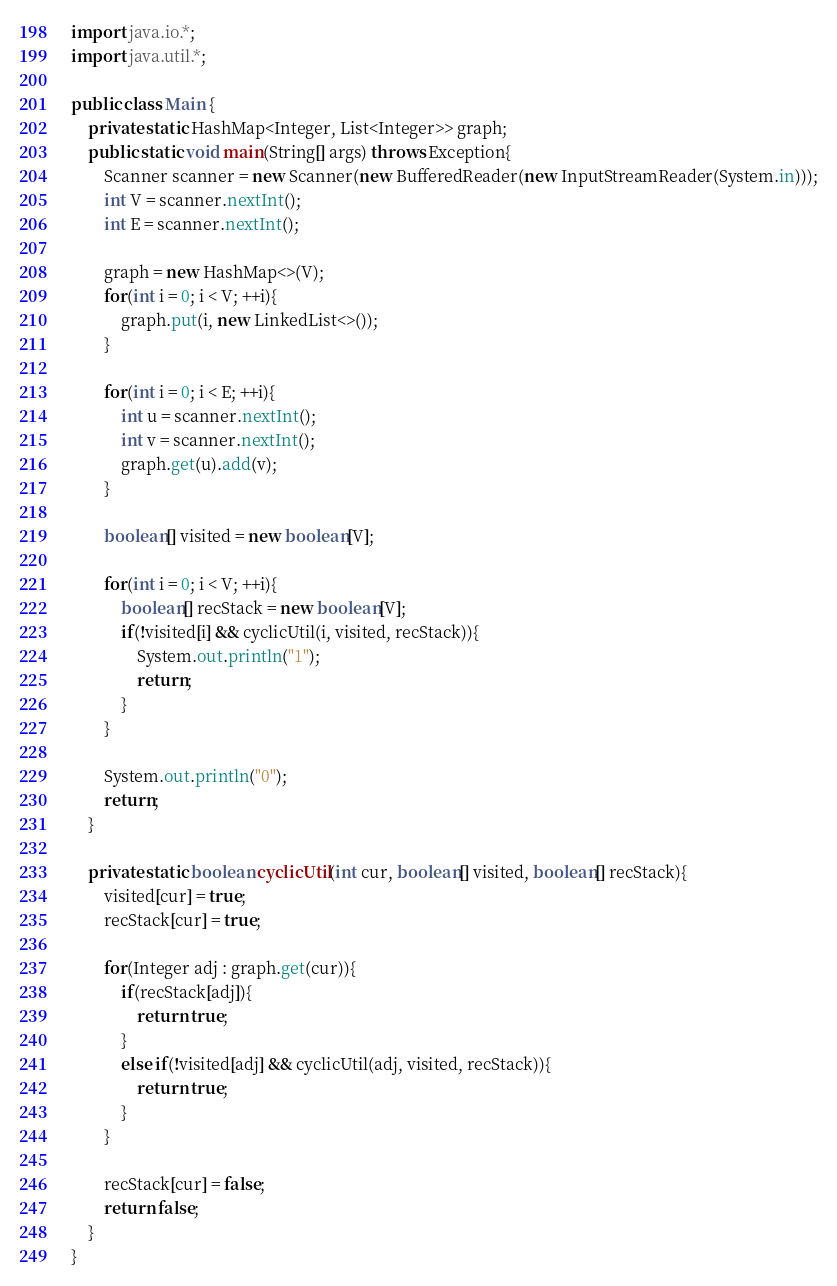<code> <loc_0><loc_0><loc_500><loc_500><_Java_>import java.io.*;
import java.util.*;

public class Main {
    private static HashMap<Integer, List<Integer>> graph;
    public static void main(String[] args) throws Exception{
        Scanner scanner = new Scanner(new BufferedReader(new InputStreamReader(System.in)));
        int V = scanner.nextInt();
        int E = scanner.nextInt();

        graph = new HashMap<>(V);
        for(int i = 0; i < V; ++i){
            graph.put(i, new LinkedList<>());
        }

        for(int i = 0; i < E; ++i){
            int u = scanner.nextInt();
            int v = scanner.nextInt();
            graph.get(u).add(v);
        }

        boolean[] visited = new boolean[V];

        for(int i = 0; i < V; ++i){
            boolean[] recStack = new boolean[V];
            if(!visited[i] && cyclicUtil(i, visited, recStack)){
                System.out.println("1");
                return;
            }
        }

        System.out.println("0");
        return;
    }

    private static boolean cyclicUtil(int cur, boolean[] visited, boolean[] recStack){
        visited[cur] = true;
        recStack[cur] = true;

        for(Integer adj : graph.get(cur)){
            if(recStack[adj]){
                return true;
            }
            else if(!visited[adj] && cyclicUtil(adj, visited, recStack)){
                return true;
            }
        }

        recStack[cur] = false;
        return false;
    }
}</code> 